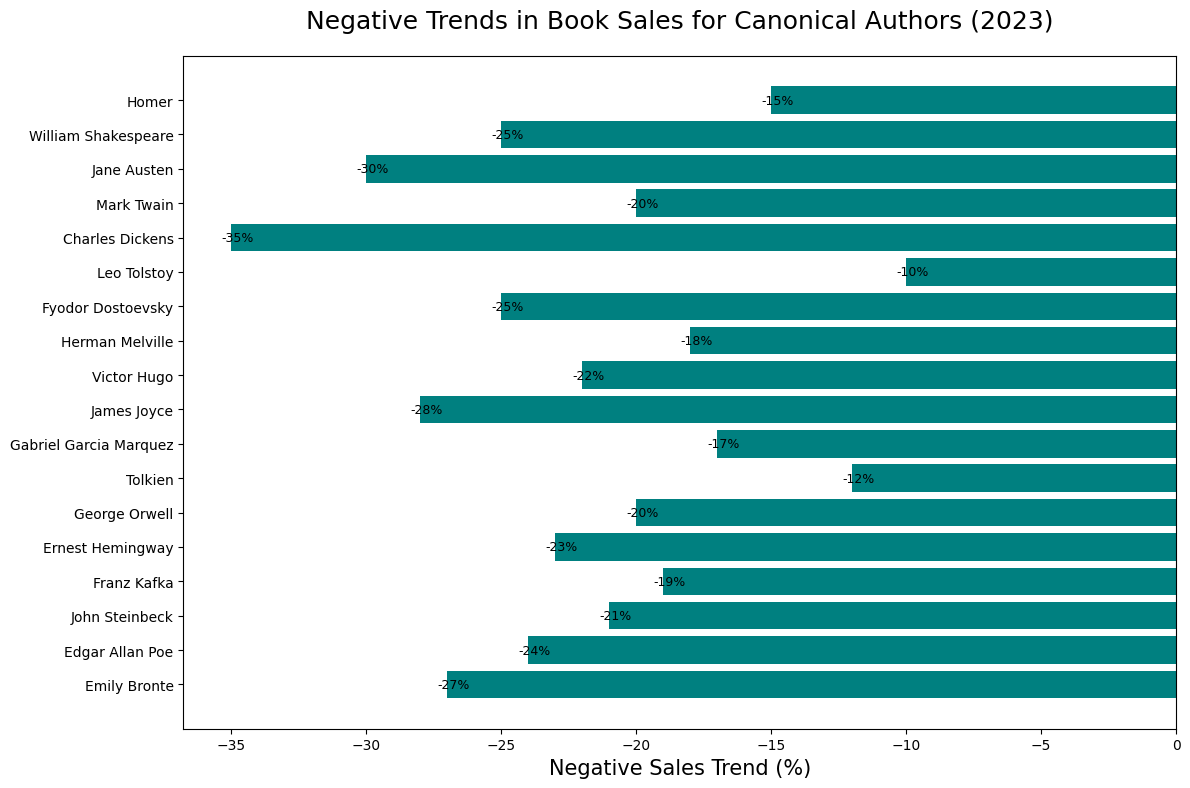Who has the most significant negative sales trend in 2023? From the bar chart, the author with the longest bar extending to the leftmost side has the most significant negative trend. Charles Dickens' bar is the longest, indicating the highest negative trend.
Answer: Charles Dickens What is the average negative sales trend of William Shakespeare and George Orwell? First, note the negative trends for these authors: William Shakespeare (-25%) and George Orwell (-20%). The average is calculated as (-25 + (-20)) / 2 = -45 / 2 = -22.5%.
Answer: -22.5% Which author has a more significant negative sales trend, Jane Austen or Emily Bronte? Compare the lengths of the bars for Jane Austen (-30%) and Emily Bronte (-27%). Since -30% is more negative than -27%, Jane Austen has a more significant negative trend.
Answer: Jane Austen What is the median negative sales trend among the authors? First, list all negative trends: -35, -30, -28, -27, -25, -25, -24, -23, -22, -21, -20, -20, -19, -18, -17, -15, -12, -10. The middle two values are -21% and -20%, so the median is the average of these two: (-21 + (-20)) / 2 = -41 / 2 = -20.5%.
Answer: -20.5% Who has a smaller negative trend: Gabriel Garcia Marquez or Mark Twain? Compare the negative trends for Gabriel Garcia Marquez (-17%) and Mark Twain (-20%). Since -17% is less negative than -20%, Gabriel Garcia Marquez has a smaller negative trend.
Answer: Gabriel Garcia Marquez How many authors have a negative sales trend greater than 20%? Count the authors with trends more negative than -20%. They are Charles Dickens (-35%), Jane Austen (-30%), Emily Bronte (-27%), James Joyce (-28%), Fyodor Dostoevsky (-25%), William Shakespeare (-25%), Edgar Allan Poe (-24%), and Ernest Hemingway (-23%). There are 8 authors in total.
Answer: 8 Which two authors have the closest negative sales trends? Look for authors with the most similar bar lengths. William Shakespeare and Fyodor Dostoevsky both have a negative trend of -25%.
Answer: William Shakespeare and Fyodor Dostoevsky 